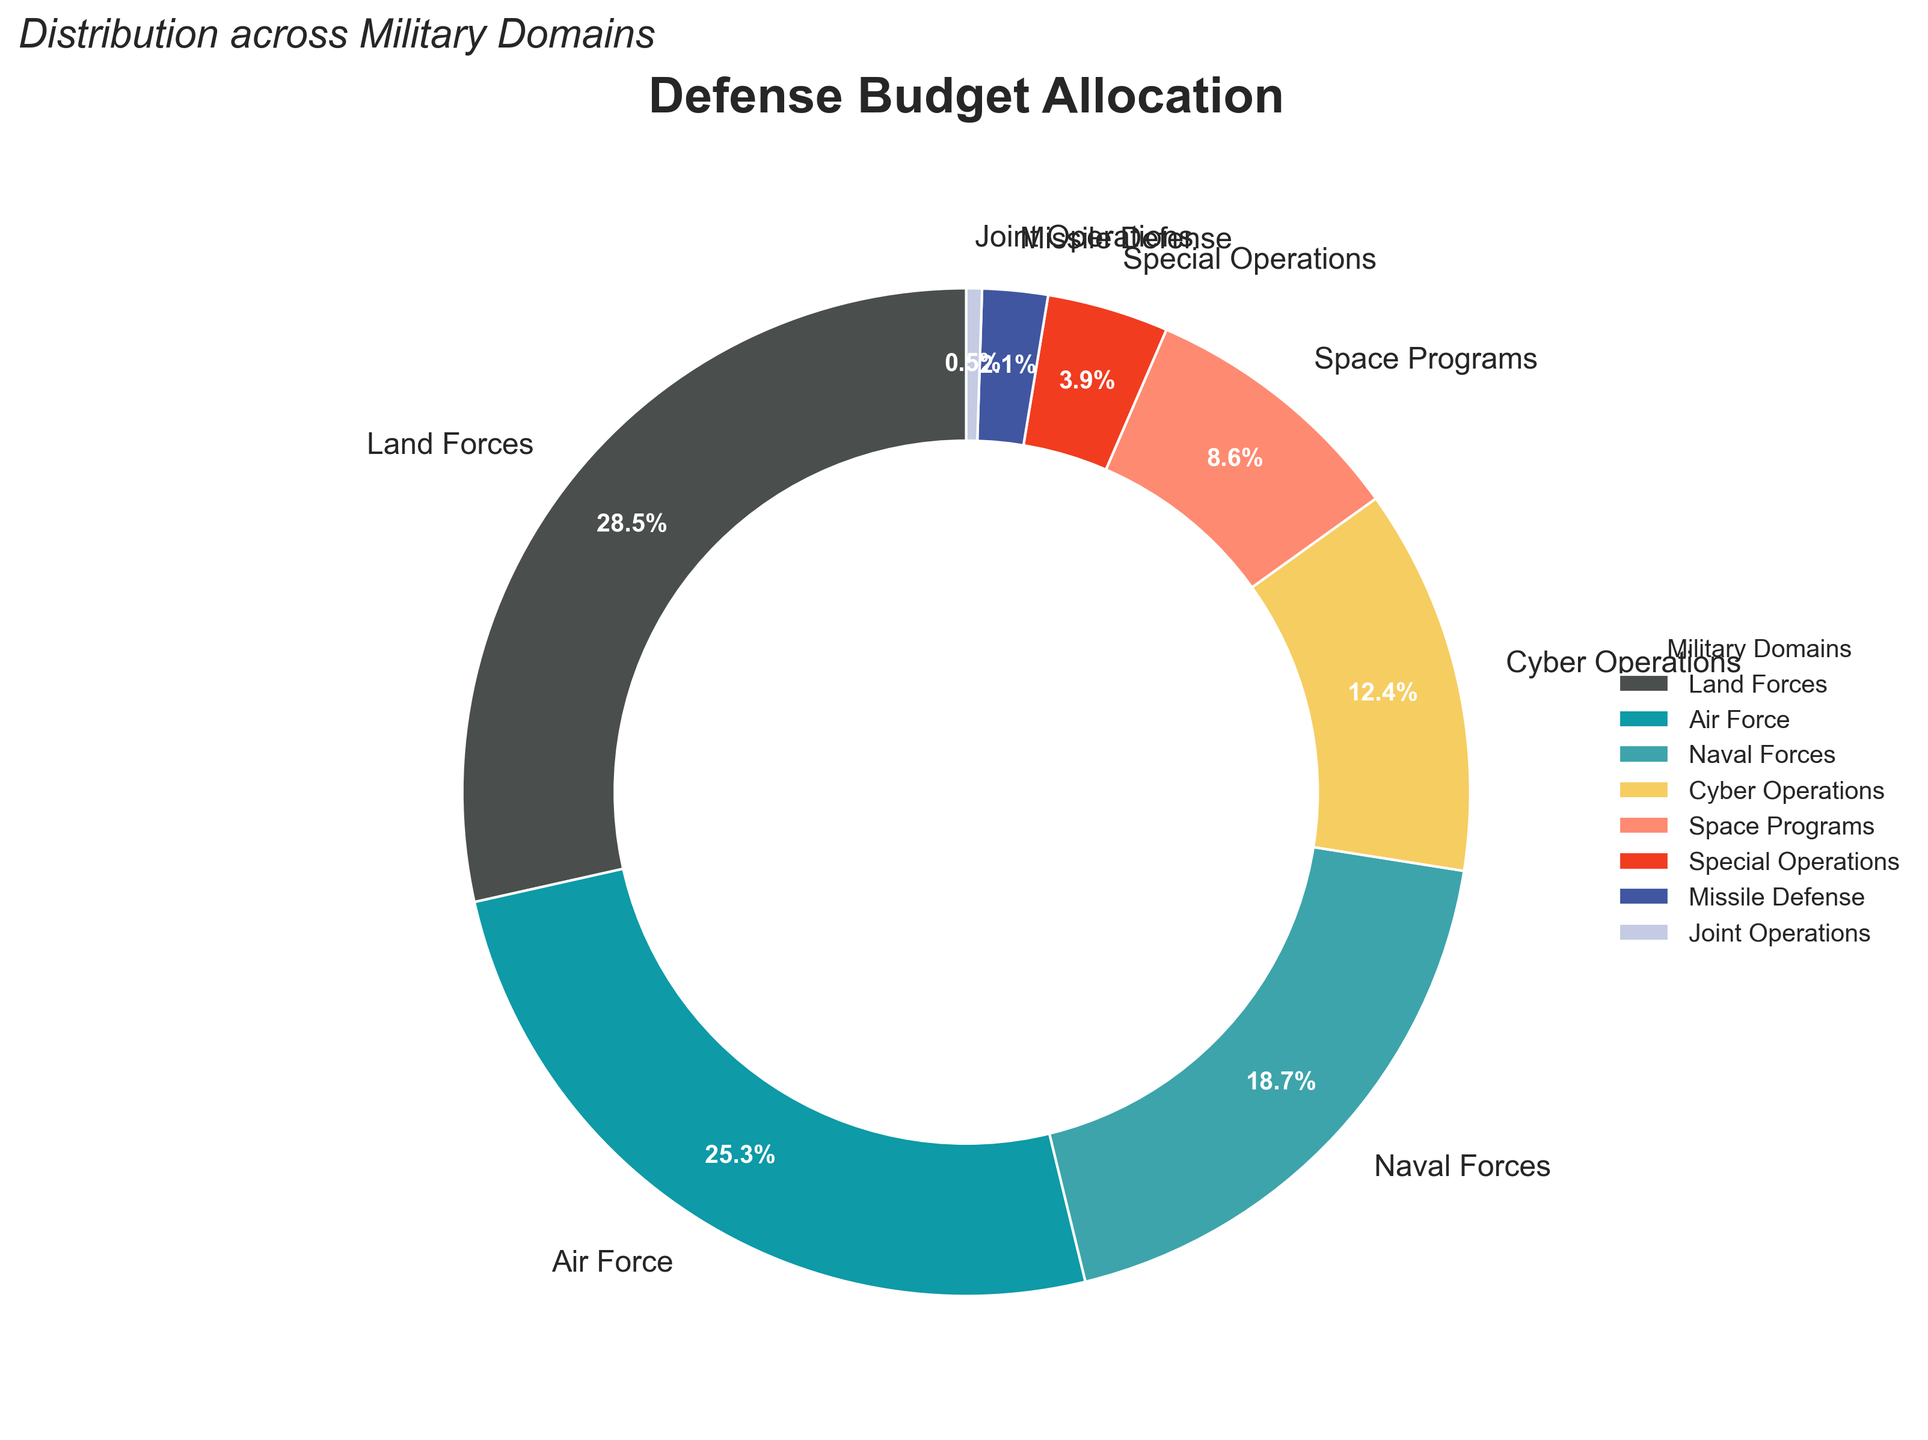What's the largest allocation of the defense budget? The slice labeled "Land Forces" has the largest allocation. By looking at the percentages displayed, "Land Forces" has 28.5%, which is the highest among all the domains.
Answer: 28.5% Which domain receives the least percentage of the defense budget? The slice labeled "Joint Operations" has the smallest allocation. By observing the displayed percentages, "Joint Operations" has 0.5%, which is the lowest among all the domains.
Answer: 0.5% How much more is allocated to Land Forces compared to Naval Forces? First, identify the percentages for "Land Forces" and "Naval Forces" which are 28.5% and 18.7%, respectively. Subtract the allocation for Naval Forces from Land Forces: 28.5% - 18.7% = 9.8%.
Answer: 9.8% What is the combined percentage allocation for Cyber Operations and Space Programs? Find the percentages for "Cyber Operations" and "Space Programs," which are 12.4% and 8.6% respectively. Add these percentages: 12.4% + 8.6% = 21%.
Answer: 21% Is the allocation for Air Force higher than Cyber Operations and Space Programs combined? The percentage for "Air Force" is 25.3%. The combined percentage for "Cyber Operations" and "Space Programs" is 12.4% + 8.6% = 21%. Since 25.3% is greater than 21%, "Air Force" has a higher allocation.
Answer: Yes What's the difference in budget allocation between Special Operations and Missile Defense? Identify the percentages for "Special Operations" and "Missile Defense," which are 3.9% and 2.1%, respectively. Subtract the allocation for Missile Defense from Special Operations: 3.9% - 2.1% = 1.8%.
Answer: 1.8% What color is used to represent Naval Forces? Looking at the pie chart, the Naval Forces slice is represented using the color blue.
Answer: Blue Is the percentage allocated to Space Programs more than half of the percentage allocated to Air Force? The percentage for "Space Programs" is 8.6%, and for "Air Force," it is 25.3%. Half of the Air Force allocation is 25.3% / 2 = 12.65%. Since 8.6% is less than 12.65%, the Space Programs allocation is not more than half of Air Force's.
Answer: No 